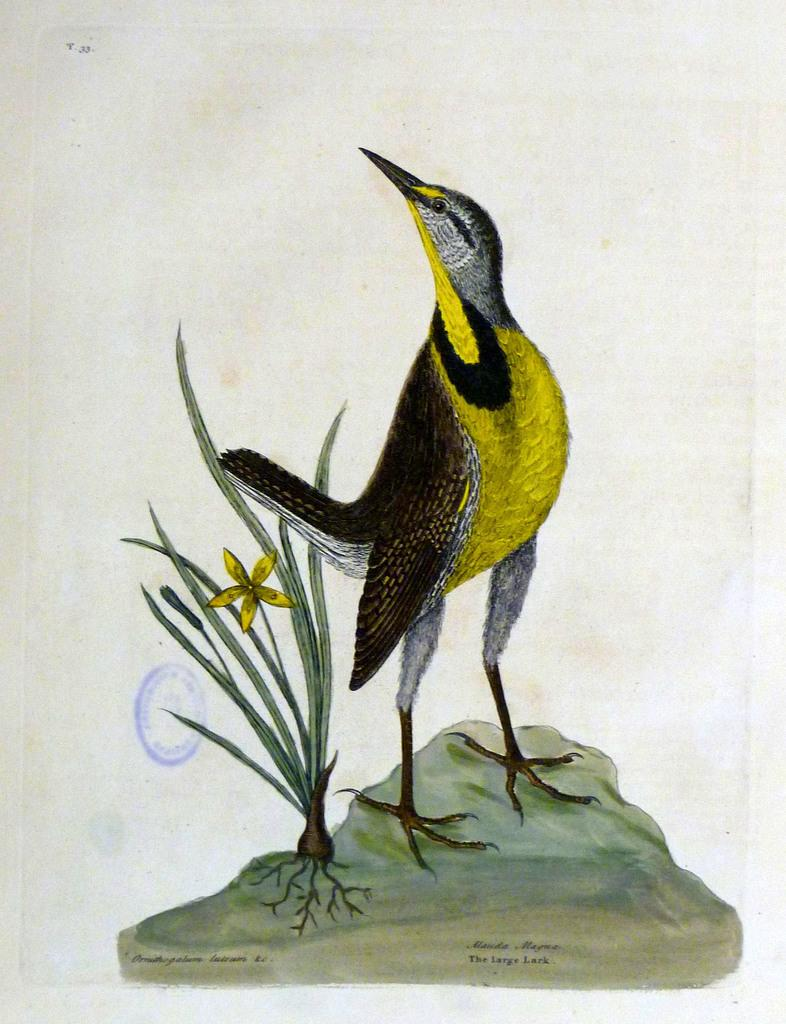What is depicted in the painting in the image? There is a painting of a bird in the image. What additional information can be found at the bottom of the painting? There is text at the bottom of the painting. What type of object can be seen in the image besides the painting? There is a stone and a plant in the image. What type of cork can be seen in the image? There is no cork present in the image. How does the team interact with the bird in the painting? There is no team present in the image, and the bird is a part of the painting, not a real bird. 